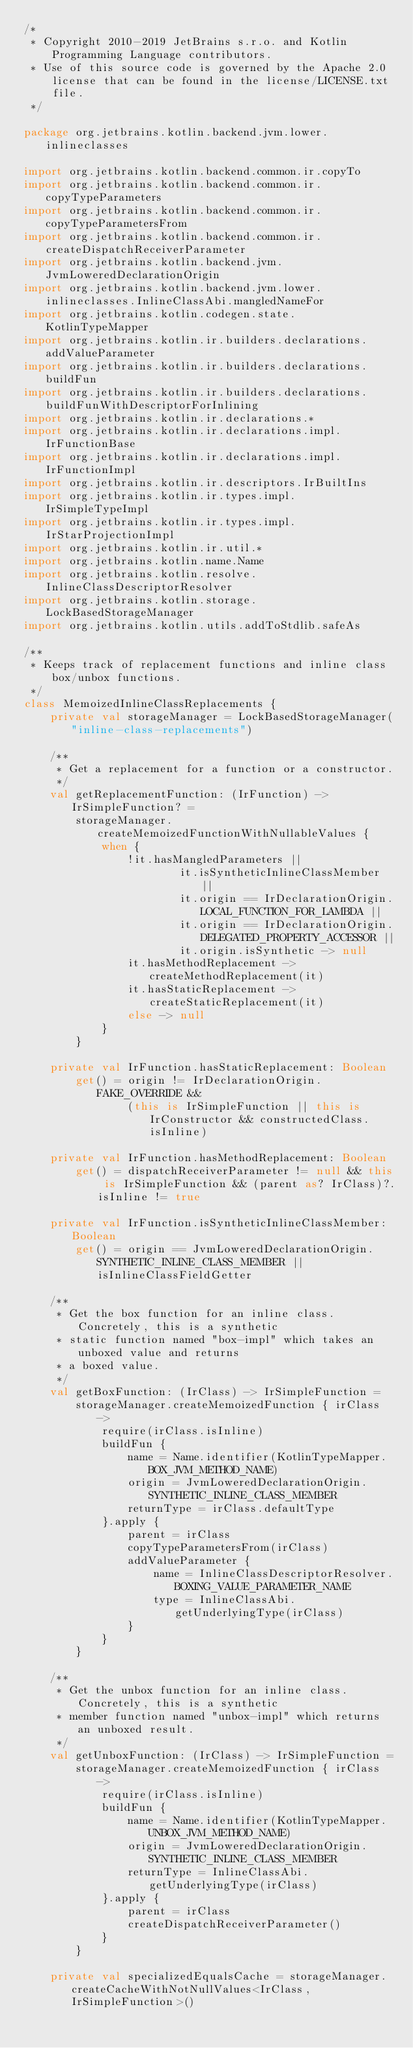<code> <loc_0><loc_0><loc_500><loc_500><_Kotlin_>/*
 * Copyright 2010-2019 JetBrains s.r.o. and Kotlin Programming Language contributors.
 * Use of this source code is governed by the Apache 2.0 license that can be found in the license/LICENSE.txt file.
 */

package org.jetbrains.kotlin.backend.jvm.lower.inlineclasses

import org.jetbrains.kotlin.backend.common.ir.copyTo
import org.jetbrains.kotlin.backend.common.ir.copyTypeParameters
import org.jetbrains.kotlin.backend.common.ir.copyTypeParametersFrom
import org.jetbrains.kotlin.backend.common.ir.createDispatchReceiverParameter
import org.jetbrains.kotlin.backend.jvm.JvmLoweredDeclarationOrigin
import org.jetbrains.kotlin.backend.jvm.lower.inlineclasses.InlineClassAbi.mangledNameFor
import org.jetbrains.kotlin.codegen.state.KotlinTypeMapper
import org.jetbrains.kotlin.ir.builders.declarations.addValueParameter
import org.jetbrains.kotlin.ir.builders.declarations.buildFun
import org.jetbrains.kotlin.ir.builders.declarations.buildFunWithDescriptorForInlining
import org.jetbrains.kotlin.ir.declarations.*
import org.jetbrains.kotlin.ir.declarations.impl.IrFunctionBase
import org.jetbrains.kotlin.ir.declarations.impl.IrFunctionImpl
import org.jetbrains.kotlin.ir.descriptors.IrBuiltIns
import org.jetbrains.kotlin.ir.types.impl.IrSimpleTypeImpl
import org.jetbrains.kotlin.ir.types.impl.IrStarProjectionImpl
import org.jetbrains.kotlin.ir.util.*
import org.jetbrains.kotlin.name.Name
import org.jetbrains.kotlin.resolve.InlineClassDescriptorResolver
import org.jetbrains.kotlin.storage.LockBasedStorageManager
import org.jetbrains.kotlin.utils.addToStdlib.safeAs

/**
 * Keeps track of replacement functions and inline class box/unbox functions.
 */
class MemoizedInlineClassReplacements {
    private val storageManager = LockBasedStorageManager("inline-class-replacements")

    /**
     * Get a replacement for a function or a constructor.
     */
    val getReplacementFunction: (IrFunction) -> IrSimpleFunction? =
        storageManager.createMemoizedFunctionWithNullableValues {
            when {
                !it.hasMangledParameters ||
                        it.isSyntheticInlineClassMember ||
                        it.origin == IrDeclarationOrigin.LOCAL_FUNCTION_FOR_LAMBDA ||
                        it.origin == IrDeclarationOrigin.DELEGATED_PROPERTY_ACCESSOR ||
                        it.origin.isSynthetic -> null
                it.hasMethodReplacement -> createMethodReplacement(it)
                it.hasStaticReplacement -> createStaticReplacement(it)
                else -> null
            }
        }

    private val IrFunction.hasStaticReplacement: Boolean
        get() = origin != IrDeclarationOrigin.FAKE_OVERRIDE &&
                (this is IrSimpleFunction || this is IrConstructor && constructedClass.isInline)

    private val IrFunction.hasMethodReplacement: Boolean
        get() = dispatchReceiverParameter != null && this is IrSimpleFunction && (parent as? IrClass)?.isInline != true

    private val IrFunction.isSyntheticInlineClassMember: Boolean
        get() = origin == JvmLoweredDeclarationOrigin.SYNTHETIC_INLINE_CLASS_MEMBER || isInlineClassFieldGetter

    /**
     * Get the box function for an inline class. Concretely, this is a synthetic
     * static function named "box-impl" which takes an unboxed value and returns
     * a boxed value.
     */
    val getBoxFunction: (IrClass) -> IrSimpleFunction =
        storageManager.createMemoizedFunction { irClass ->
            require(irClass.isInline)
            buildFun {
                name = Name.identifier(KotlinTypeMapper.BOX_JVM_METHOD_NAME)
                origin = JvmLoweredDeclarationOrigin.SYNTHETIC_INLINE_CLASS_MEMBER
                returnType = irClass.defaultType
            }.apply {
                parent = irClass
                copyTypeParametersFrom(irClass)
                addValueParameter {
                    name = InlineClassDescriptorResolver.BOXING_VALUE_PARAMETER_NAME
                    type = InlineClassAbi.getUnderlyingType(irClass)
                }
            }
        }

    /**
     * Get the unbox function for an inline class. Concretely, this is a synthetic
     * member function named "unbox-impl" which returns an unboxed result.
     */
    val getUnboxFunction: (IrClass) -> IrSimpleFunction =
        storageManager.createMemoizedFunction { irClass ->
            require(irClass.isInline)
            buildFun {
                name = Name.identifier(KotlinTypeMapper.UNBOX_JVM_METHOD_NAME)
                origin = JvmLoweredDeclarationOrigin.SYNTHETIC_INLINE_CLASS_MEMBER
                returnType = InlineClassAbi.getUnderlyingType(irClass)
            }.apply {
                parent = irClass
                createDispatchReceiverParameter()
            }
        }

    private val specializedEqualsCache = storageManager.createCacheWithNotNullValues<IrClass, IrSimpleFunction>()</code> 